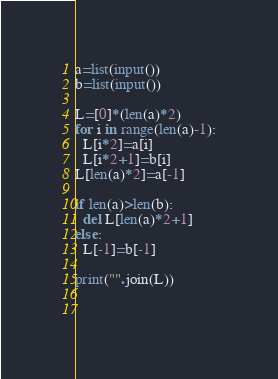<code> <loc_0><loc_0><loc_500><loc_500><_Python_>a=list(input())
b=list(input())

L=[0]*(len(a)*2)
for i in range(len(a)-1):
  L[i*2]=a[i]
  L[i*2+1]=b[i]
L[len(a)*2]=a[-1]

if len(a)>len(b):
  del L[len(a)*2+1]
else:
  L[-1]=b[-1]

print("".join(L))
    
    </code> 